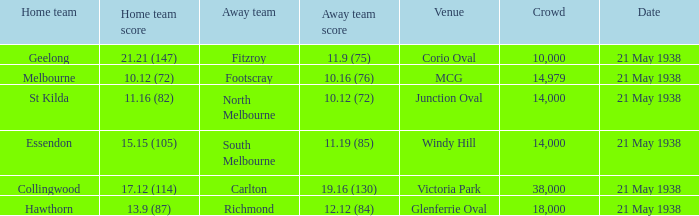Which Home team has a Venue of mcg? Melbourne. 